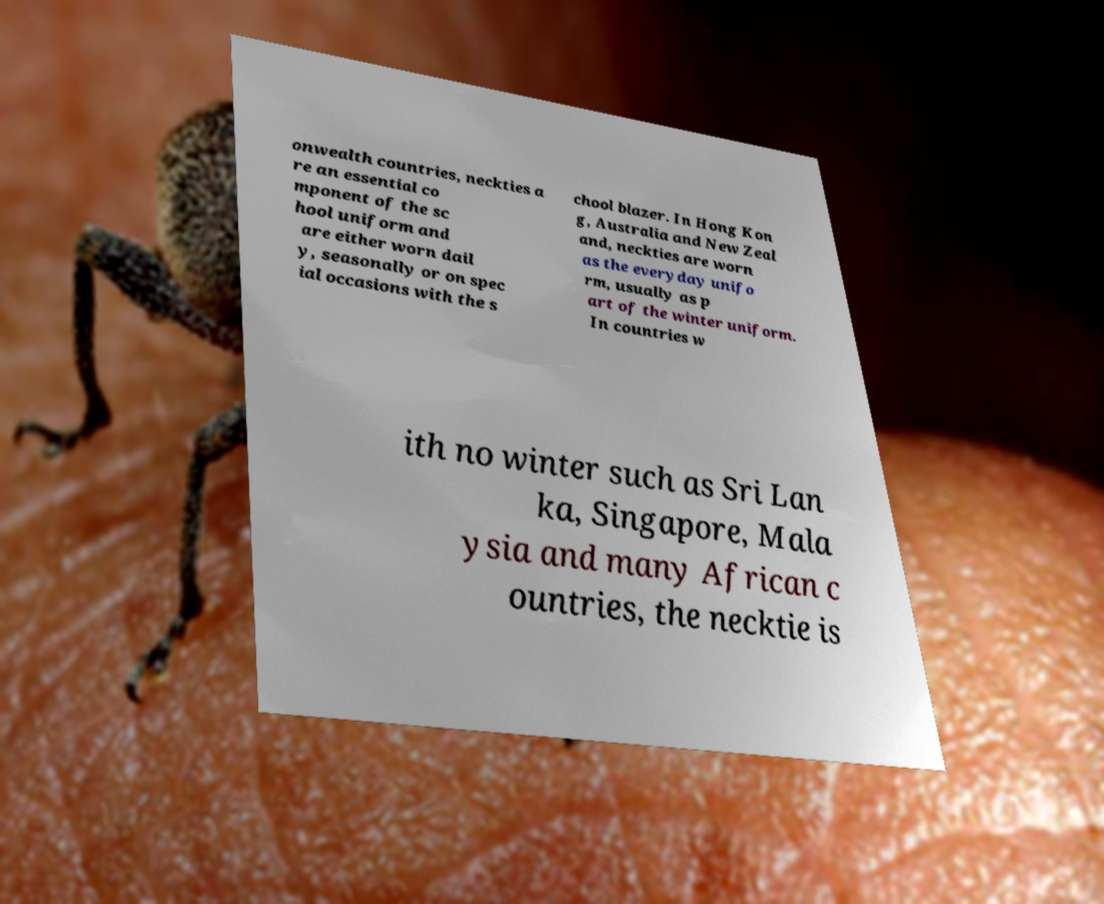Could you assist in decoding the text presented in this image and type it out clearly? onwealth countries, neckties a re an essential co mponent of the sc hool uniform and are either worn dail y, seasonally or on spec ial occasions with the s chool blazer. In Hong Kon g, Australia and New Zeal and, neckties are worn as the everyday unifo rm, usually as p art of the winter uniform. In countries w ith no winter such as Sri Lan ka, Singapore, Mala ysia and many African c ountries, the necktie is 